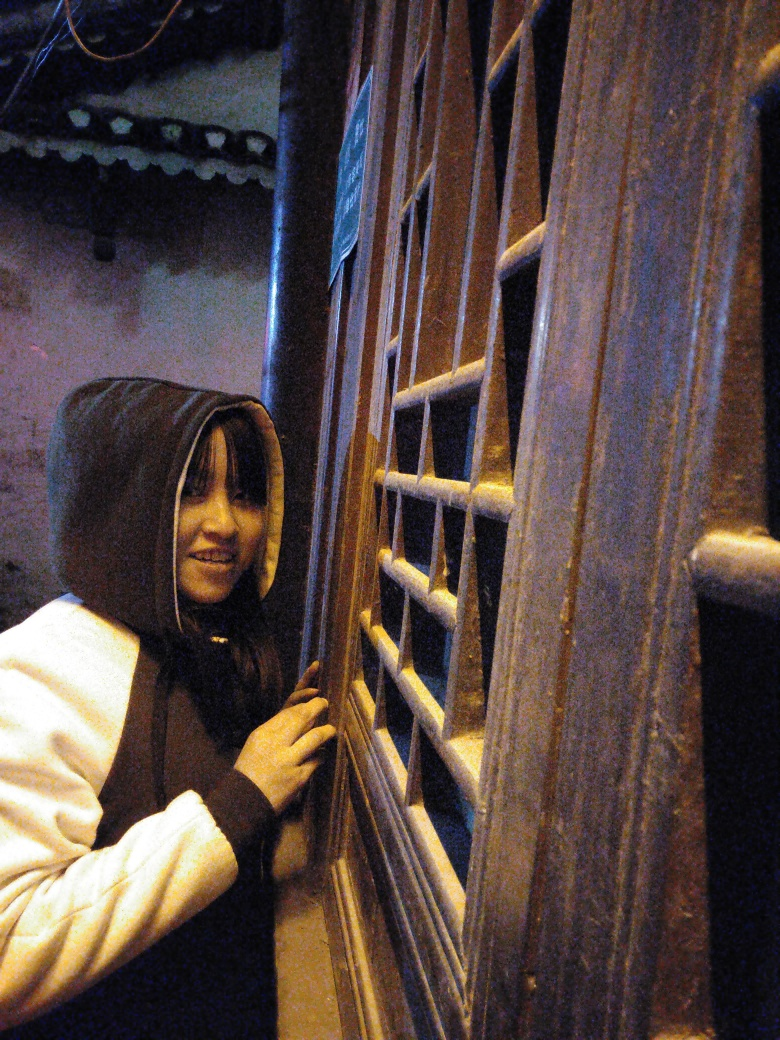What emotions does the person in the image appear to be experiencing? The person in the image appears to have a contemplative or curious expression, possibly looking out with anticipation or observing something of interest outside of the frame. 